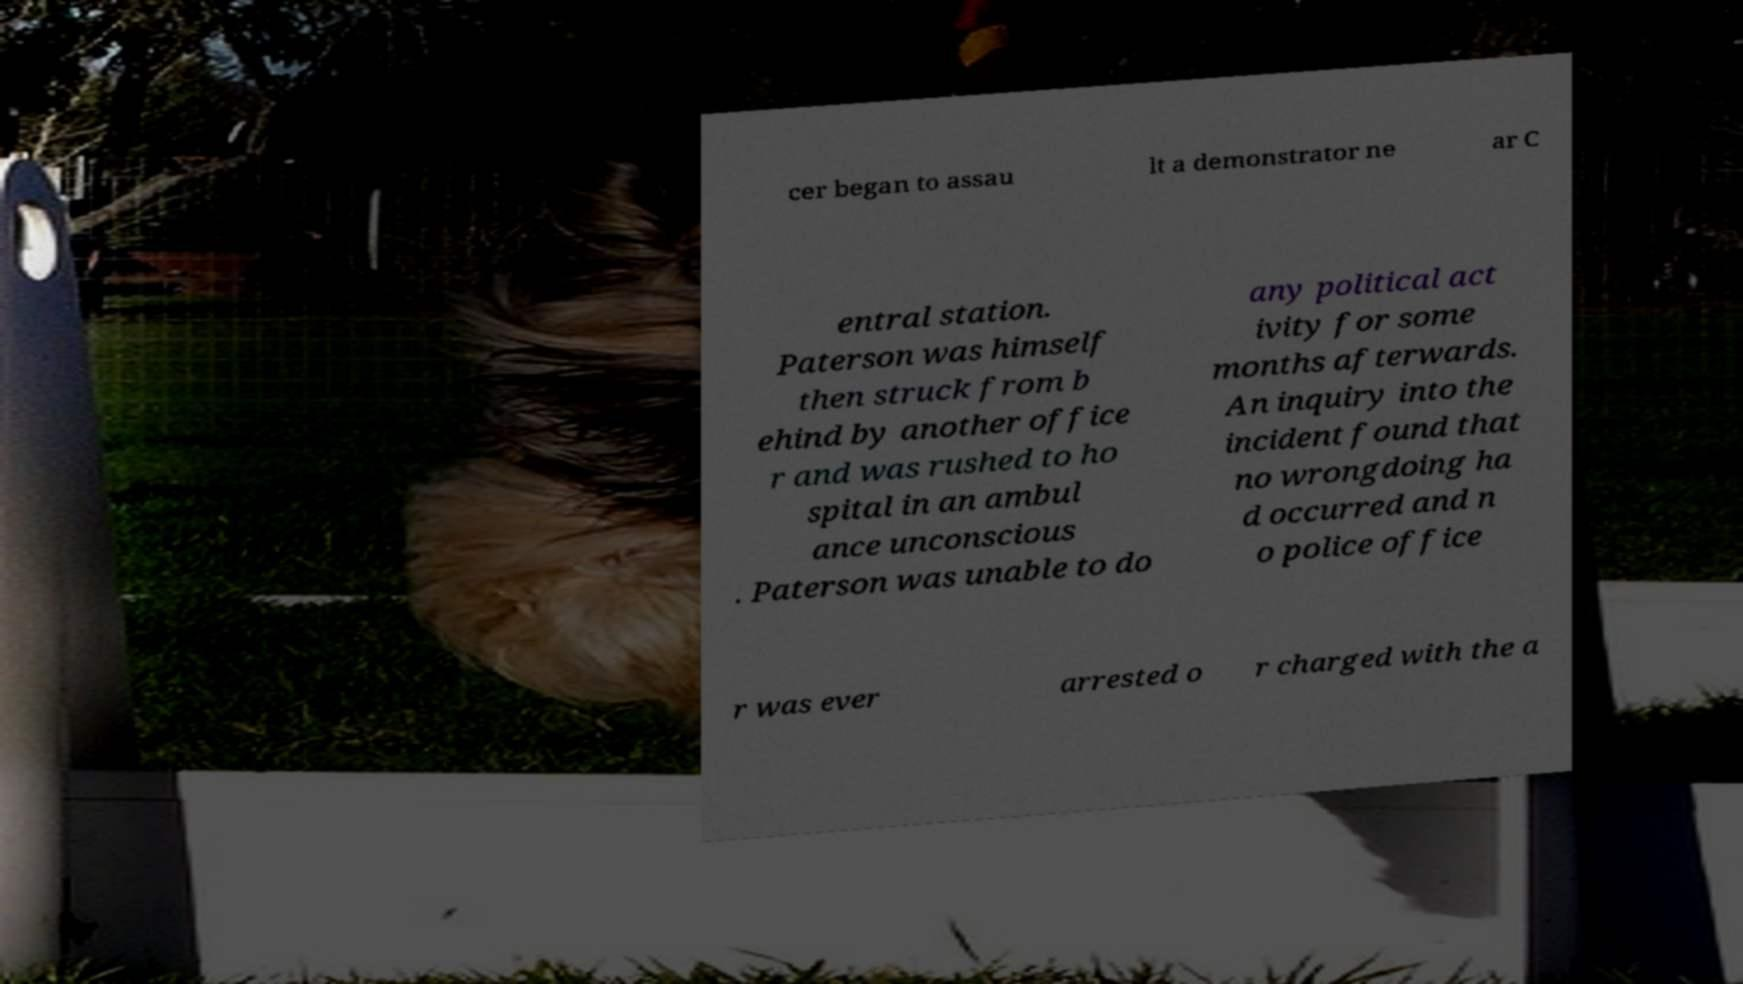There's text embedded in this image that I need extracted. Can you transcribe it verbatim? cer began to assau lt a demonstrator ne ar C entral station. Paterson was himself then struck from b ehind by another office r and was rushed to ho spital in an ambul ance unconscious . Paterson was unable to do any political act ivity for some months afterwards. An inquiry into the incident found that no wrongdoing ha d occurred and n o police office r was ever arrested o r charged with the a 